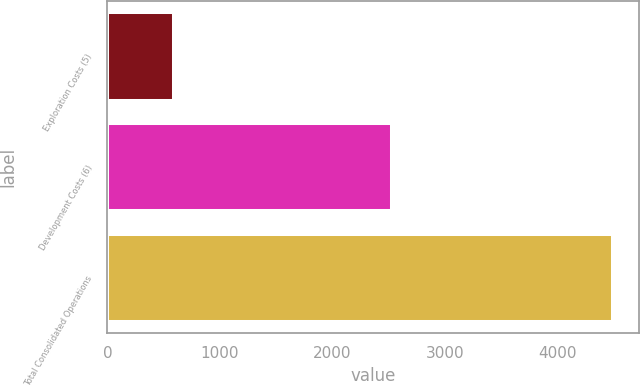Convert chart to OTSL. <chart><loc_0><loc_0><loc_500><loc_500><bar_chart><fcel>Exploration Costs (5)<fcel>Development Costs (6)<fcel>Total Consolidated Operations<nl><fcel>593<fcel>2532<fcel>4499<nl></chart> 